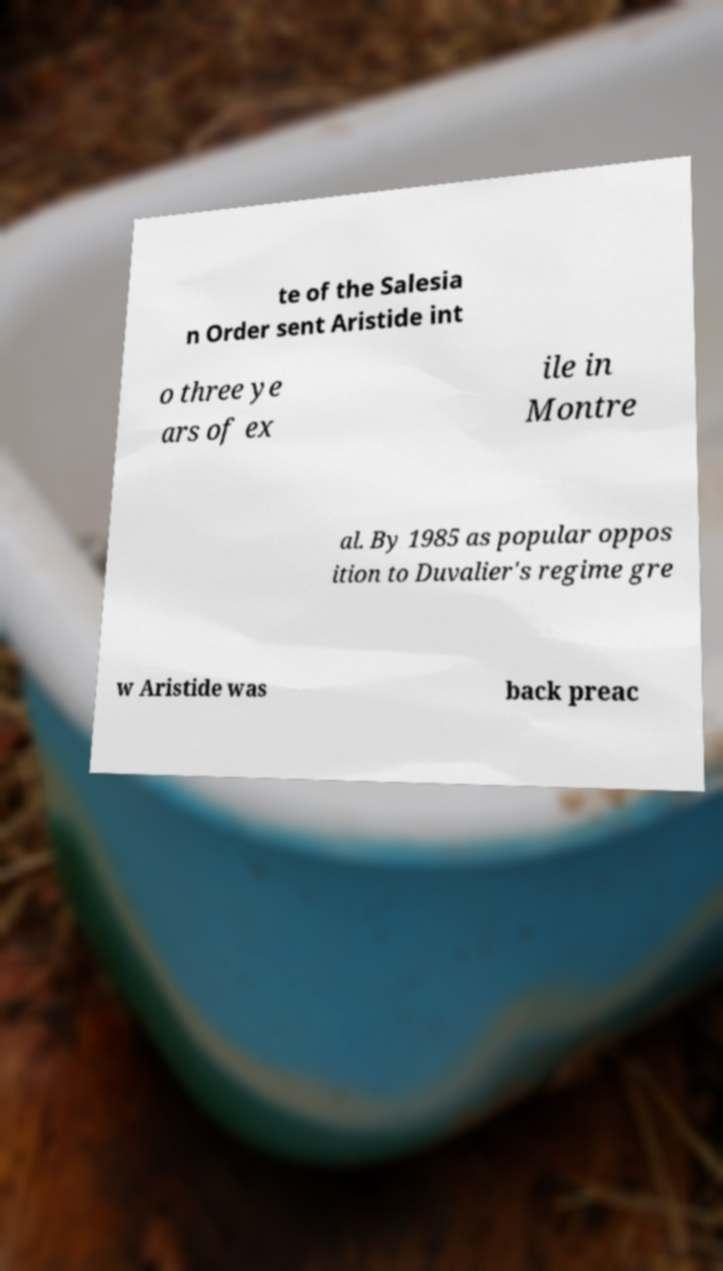What messages or text are displayed in this image? I need them in a readable, typed format. te of the Salesia n Order sent Aristide int o three ye ars of ex ile in Montre al. By 1985 as popular oppos ition to Duvalier's regime gre w Aristide was back preac 